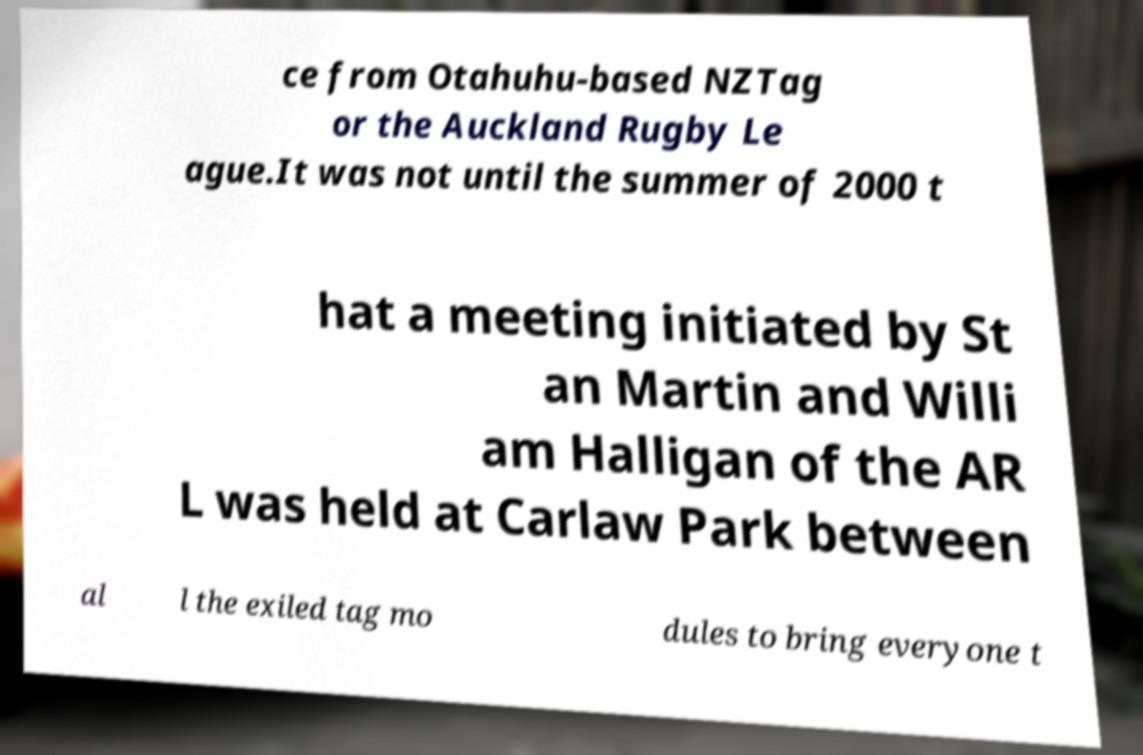There's text embedded in this image that I need extracted. Can you transcribe it verbatim? ce from Otahuhu-based NZTag or the Auckland Rugby Le ague.It was not until the summer of 2000 t hat a meeting initiated by St an Martin and Willi am Halligan of the AR L was held at Carlaw Park between al l the exiled tag mo dules to bring everyone t 